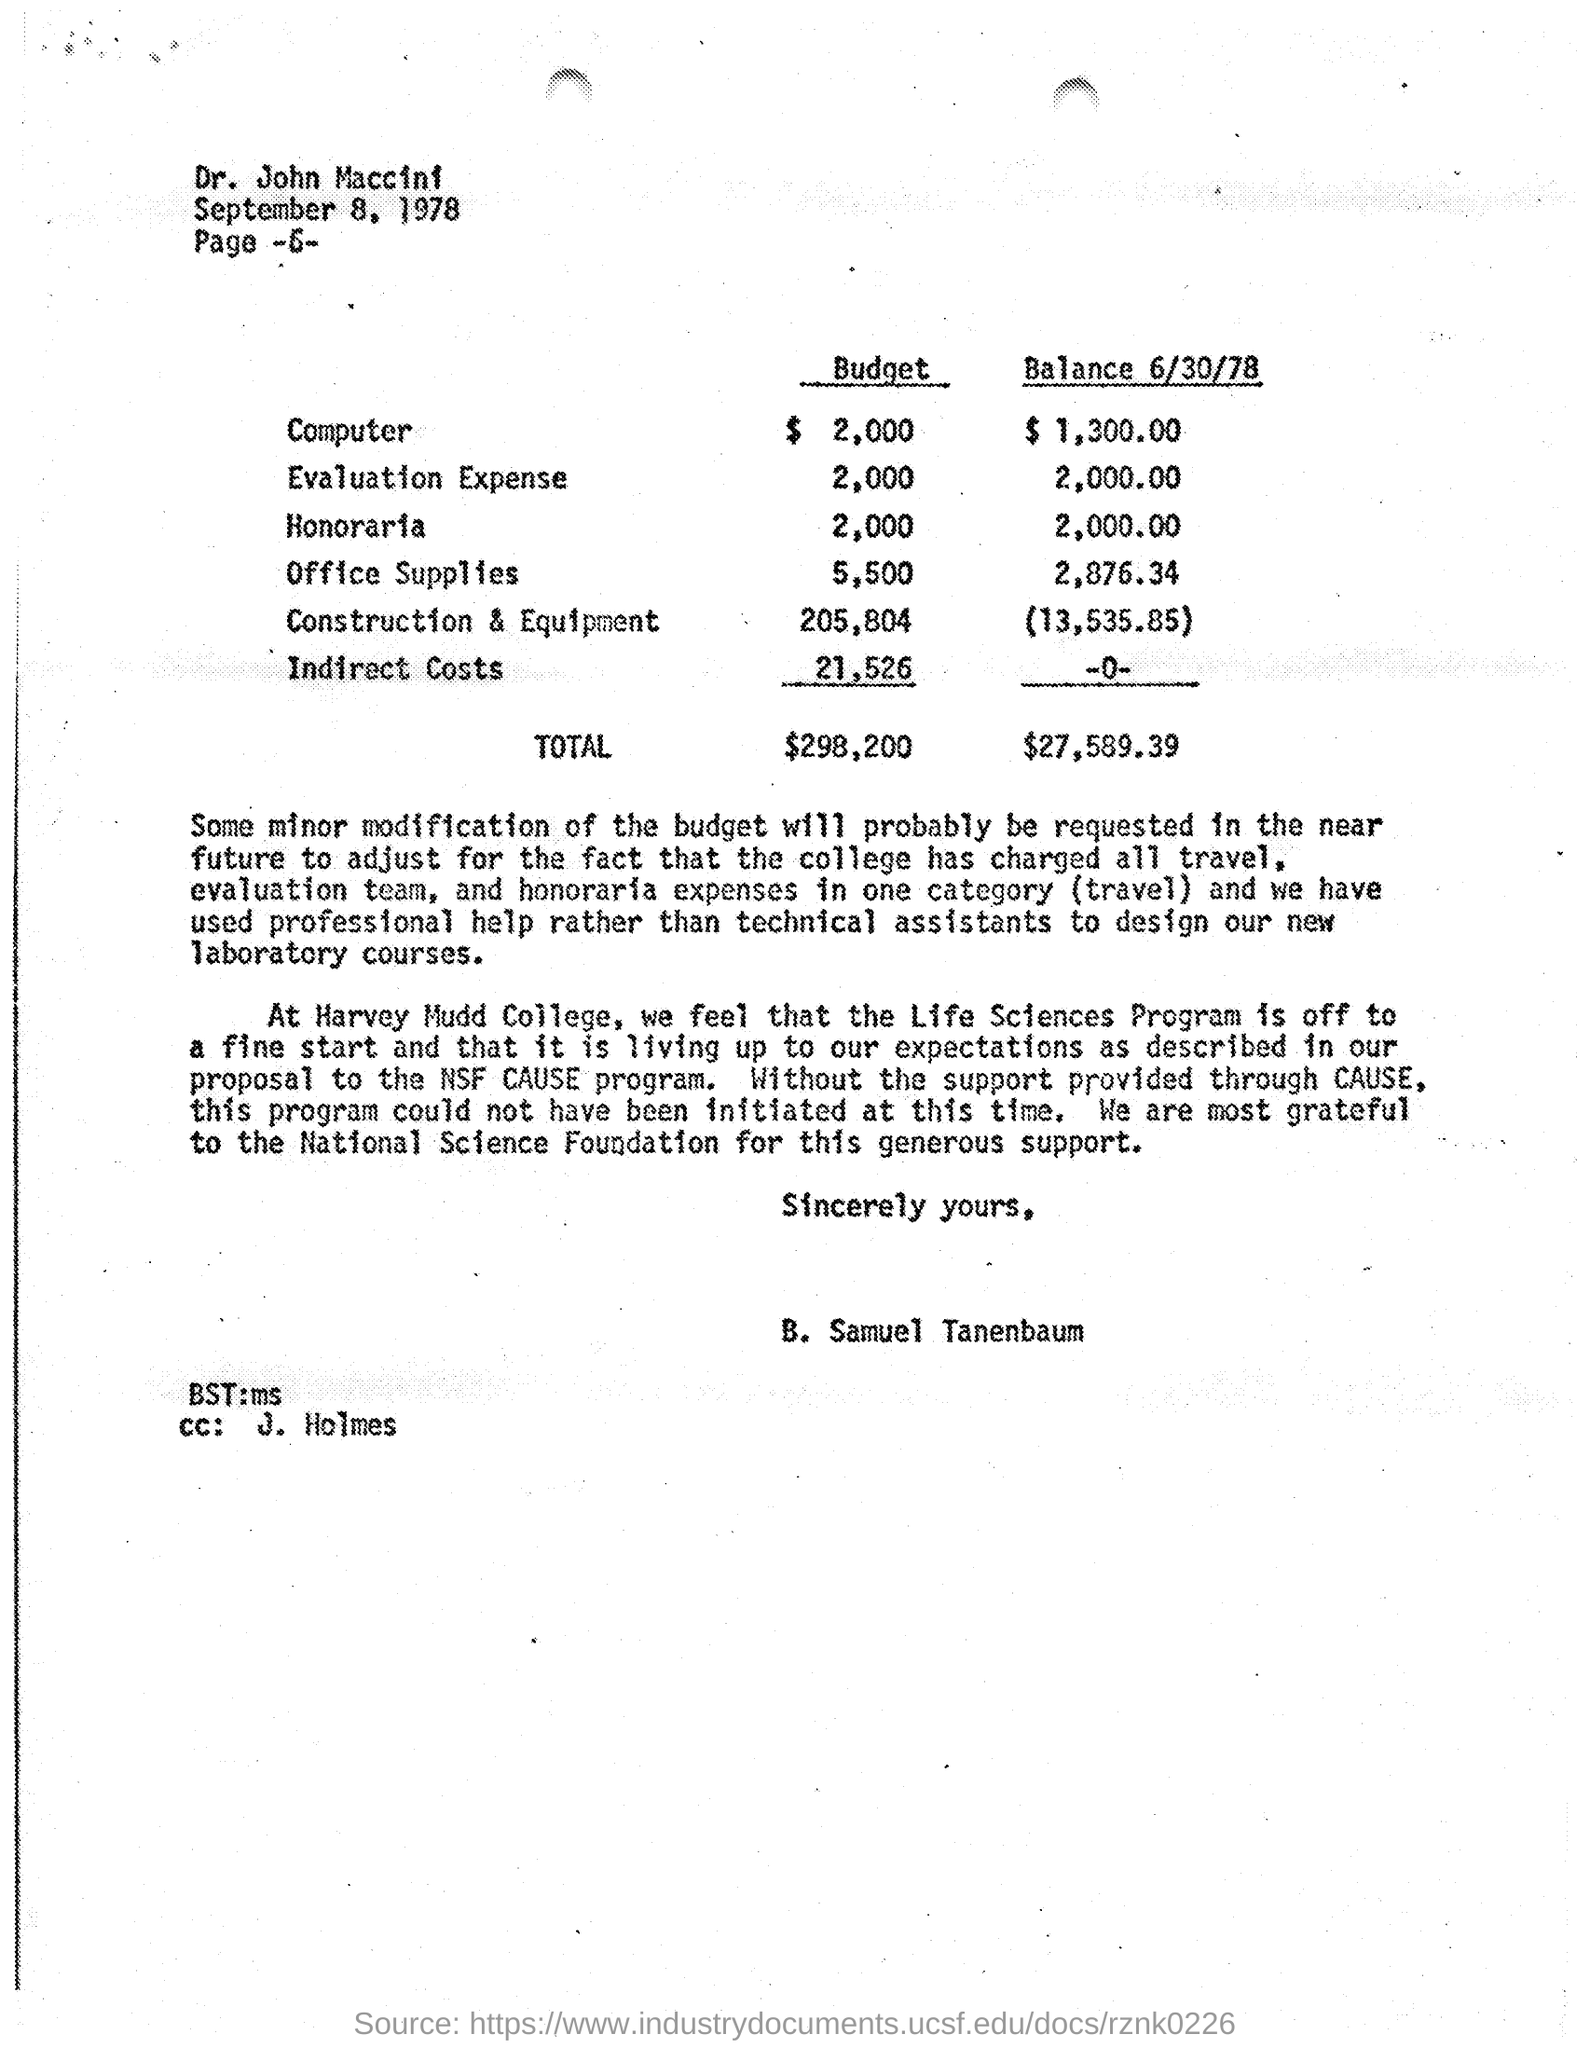List a handful of essential elements in this visual. The National Science Foundation supported the college for the program. The total balance amount is $27,589.39. The estimated budget for honoraria is $2,000. The name of the college mentioned is Harvey Mudd College. An estimate of 205,804 dollars was provided for construction and equipment costs. 